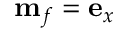Convert formula to latex. <formula><loc_0><loc_0><loc_500><loc_500>m _ { f } = e _ { x }</formula> 